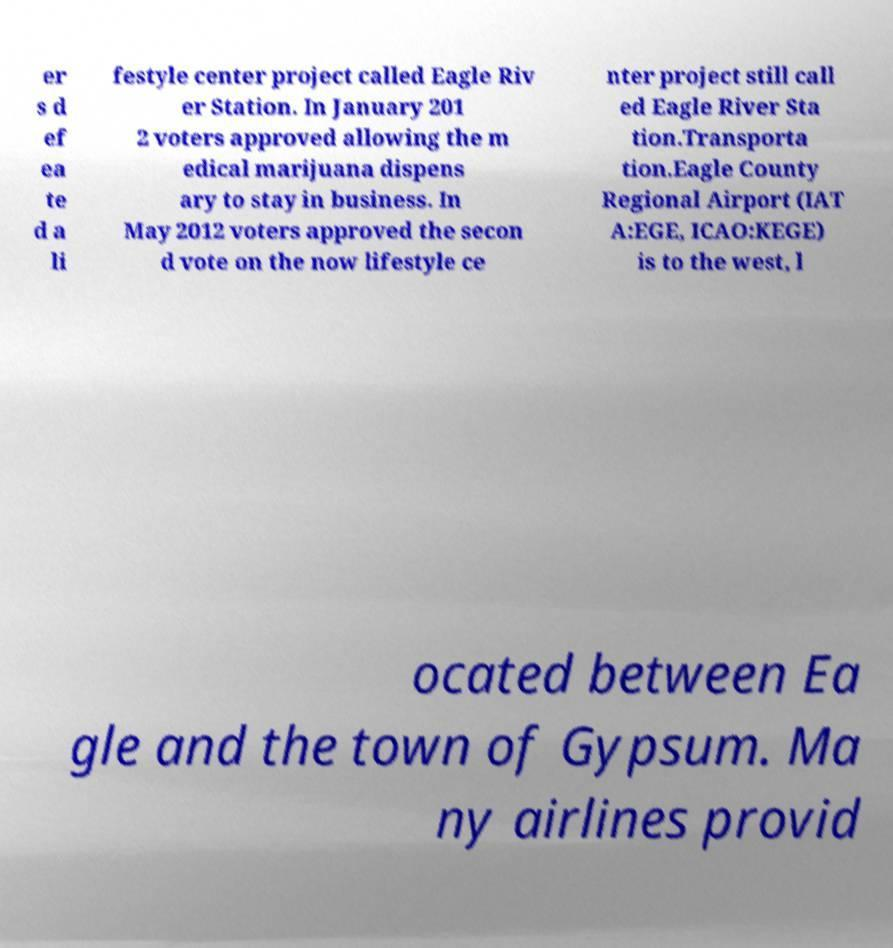Please identify and transcribe the text found in this image. er s d ef ea te d a li festyle center project called Eagle Riv er Station. In January 201 2 voters approved allowing the m edical marijuana dispens ary to stay in business. In May 2012 voters approved the secon d vote on the now lifestyle ce nter project still call ed Eagle River Sta tion.Transporta tion.Eagle County Regional Airport (IAT A:EGE, ICAO:KEGE) is to the west, l ocated between Ea gle and the town of Gypsum. Ma ny airlines provid 